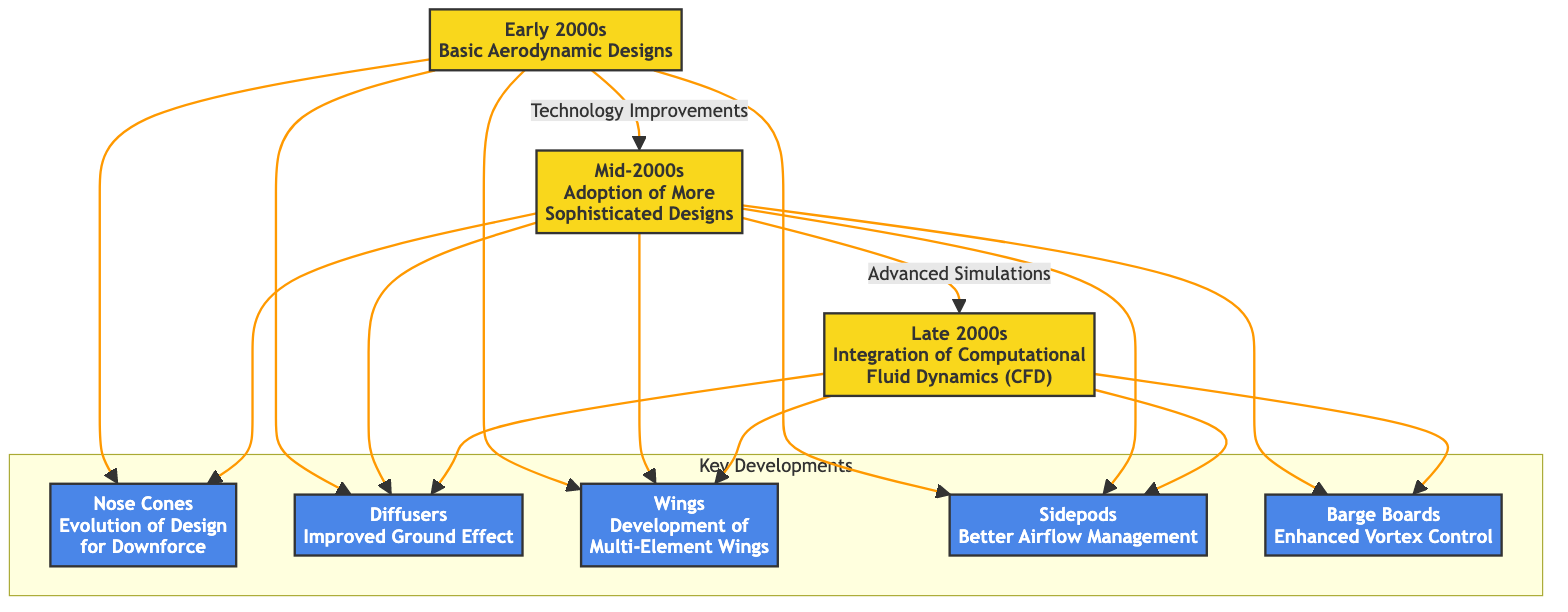How many eras are represented in the diagram? The diagram contains three distinct eras: Early 2000s, Mid-2000s, and Late 2000s. Counting these eras gives a total of three.
Answer: 3 What major development links the Early 2000s and Mid-2000s? The connection between the Early 2000s and Mid-2000s is labeled "Technology Improvements," indicating a progression in aerodynamic designs.
Answer: Technology Improvements Which component evolved in the Late 2000s to improve ground effect? The component that improved ground effect in the Late 2000s is the "Diffusers." This component is specifically mentioned under this era related to advanced techniques in aerodynamics.
Answer: Diffusers In which era do we see the adoption of barge boards? The barge boards were adopted in the Mid-2000s, as indicated by their connection from that era in the diagram flow.
Answer: Mid-2000s What component is linked to the integration of Computational Fluid Dynamics? The components linked to the integration of Computational Fluid Dynamics (CFD) in the Late 2000s are "Diffusers," "Wings," "Sidepods," and "Barge Boards." This indicates that these design aspects were improved through CFD.
Answer: Diffusers, Wings, Sidepods, Barge Boards What is the relationship between the components and the Early 2000s era? The Early 2000s era shows connections to "Nose Cones," "Diffusers," "Wings," and "Sidepods," suggesting that these components were foundational in the basic aerodynamic designs of that time.
Answer: Nose Cones, Diffusers, Wings, Sidepods Which era follows the Mid-2000s? The era that follows the Mid-2000s is the Late 2000s, as represented in the diagram with a directional arrow indicating progression.
Answer: Late 2000s How many components are listed in the diagram? There are five components listed in the diagram: Nose Cones, Diffusers, Wings, Sidepods, and Barge Boards. Counting each of these gives a total of five components.
Answer: 5 